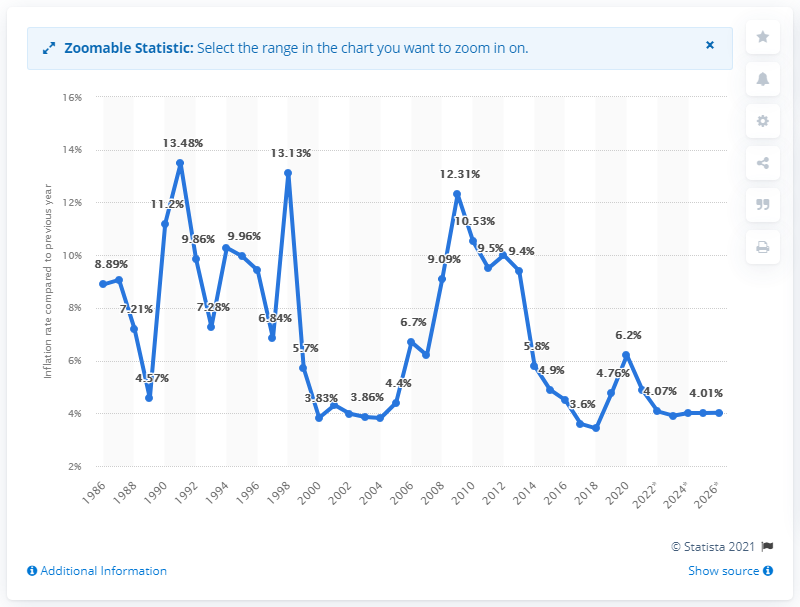Give some essential details in this illustration. In 2020, India's inflation rate was 6.2%. 